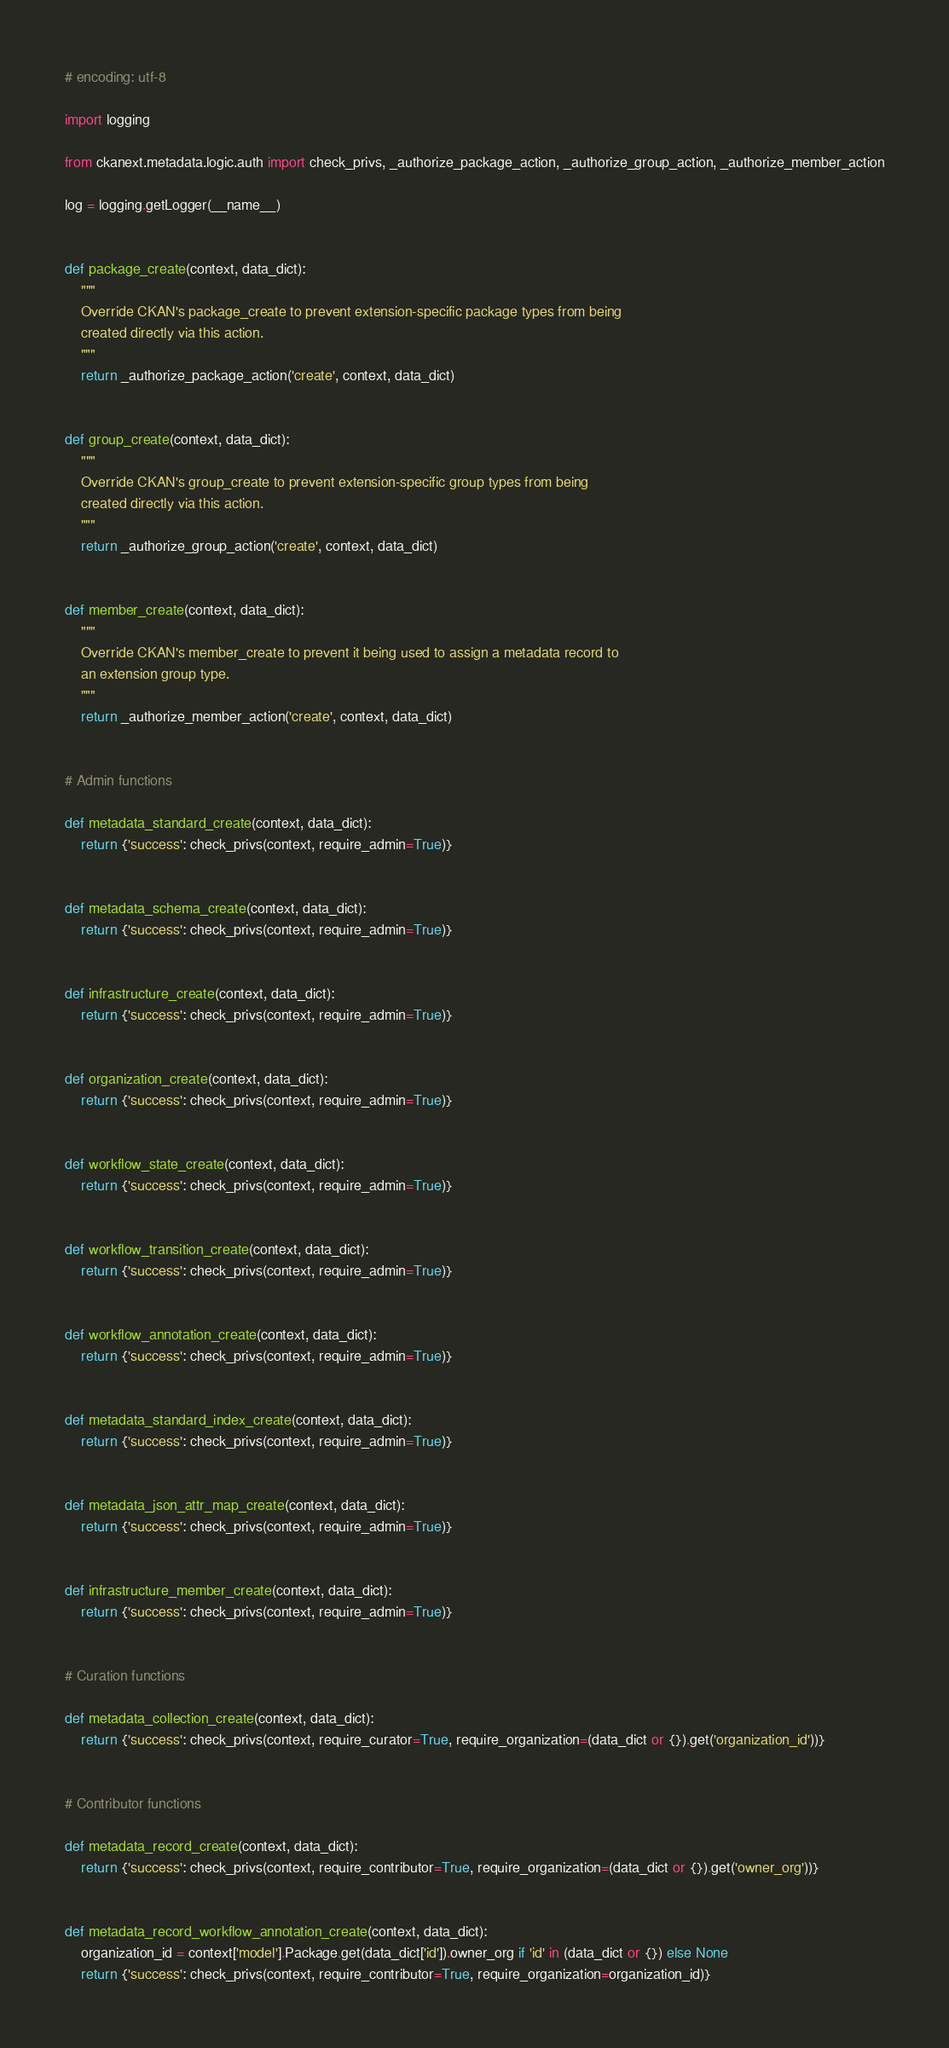Convert code to text. <code><loc_0><loc_0><loc_500><loc_500><_Python_># encoding: utf-8

import logging

from ckanext.metadata.logic.auth import check_privs, _authorize_package_action, _authorize_group_action, _authorize_member_action

log = logging.getLogger(__name__)


def package_create(context, data_dict):
    """
    Override CKAN's package_create to prevent extension-specific package types from being
    created directly via this action.
    """
    return _authorize_package_action('create', context, data_dict)


def group_create(context, data_dict):
    """
    Override CKAN's group_create to prevent extension-specific group types from being
    created directly via this action.
    """
    return _authorize_group_action('create', context, data_dict)


def member_create(context, data_dict):
    """
    Override CKAN's member_create to prevent it being used to assign a metadata record to
    an extension group type.
    """
    return _authorize_member_action('create', context, data_dict)


# Admin functions

def metadata_standard_create(context, data_dict):
    return {'success': check_privs(context, require_admin=True)}


def metadata_schema_create(context, data_dict):
    return {'success': check_privs(context, require_admin=True)}


def infrastructure_create(context, data_dict):
    return {'success': check_privs(context, require_admin=True)}


def organization_create(context, data_dict):
    return {'success': check_privs(context, require_admin=True)}


def workflow_state_create(context, data_dict):
    return {'success': check_privs(context, require_admin=True)}


def workflow_transition_create(context, data_dict):
    return {'success': check_privs(context, require_admin=True)}


def workflow_annotation_create(context, data_dict):
    return {'success': check_privs(context, require_admin=True)}


def metadata_standard_index_create(context, data_dict):
    return {'success': check_privs(context, require_admin=True)}


def metadata_json_attr_map_create(context, data_dict):
    return {'success': check_privs(context, require_admin=True)}


def infrastructure_member_create(context, data_dict):
    return {'success': check_privs(context, require_admin=True)}


# Curation functions

def metadata_collection_create(context, data_dict):
    return {'success': check_privs(context, require_curator=True, require_organization=(data_dict or {}).get('organization_id'))}


# Contributor functions

def metadata_record_create(context, data_dict):
    return {'success': check_privs(context, require_contributor=True, require_organization=(data_dict or {}).get('owner_org'))}


def metadata_record_workflow_annotation_create(context, data_dict):
    organization_id = context['model'].Package.get(data_dict['id']).owner_org if 'id' in (data_dict or {}) else None
    return {'success': check_privs(context, require_contributor=True, require_organization=organization_id)}
</code> 